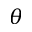Convert formula to latex. <formula><loc_0><loc_0><loc_500><loc_500>\theta</formula> 